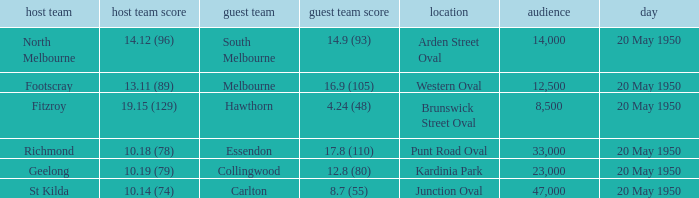What was the largest crowd to view a game where the away team scored 17.8 (110)? 33000.0. 